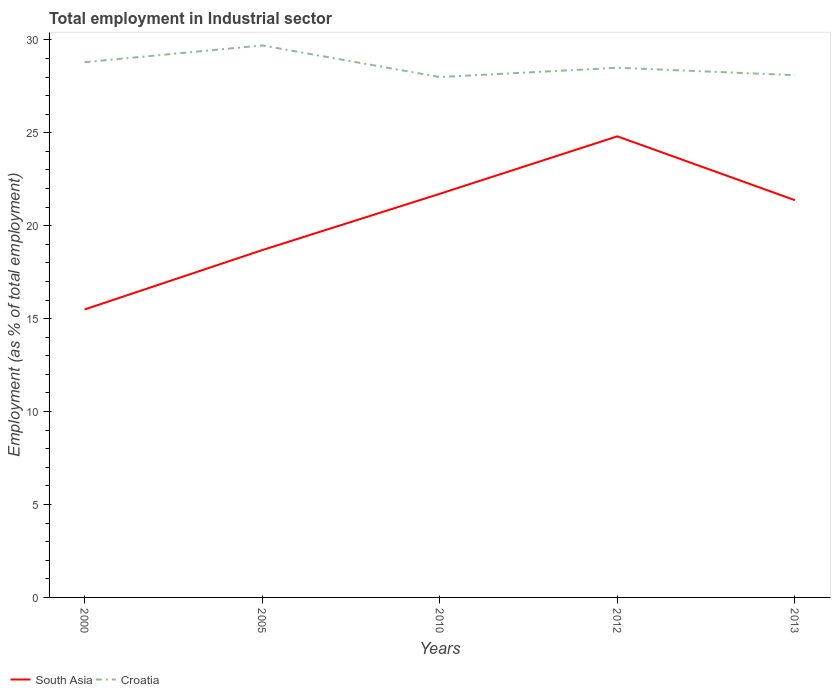How many different coloured lines are there?
Your response must be concise. 2. Does the line corresponding to South Asia intersect with the line corresponding to Croatia?
Offer a very short reply. No. Is the number of lines equal to the number of legend labels?
Make the answer very short. Yes. Across all years, what is the maximum employment in industrial sector in South Asia?
Give a very brief answer. 15.49. In which year was the employment in industrial sector in South Asia maximum?
Provide a succinct answer. 2000. What is the total employment in industrial sector in Croatia in the graph?
Offer a terse response. 0.3. What is the difference between the highest and the second highest employment in industrial sector in South Asia?
Offer a terse response. 9.31. Is the employment in industrial sector in Croatia strictly greater than the employment in industrial sector in South Asia over the years?
Ensure brevity in your answer.  No. How many lines are there?
Offer a very short reply. 2. How many years are there in the graph?
Make the answer very short. 5. What is the difference between two consecutive major ticks on the Y-axis?
Your answer should be very brief. 5. Are the values on the major ticks of Y-axis written in scientific E-notation?
Offer a very short reply. No. Does the graph contain any zero values?
Your response must be concise. No. Where does the legend appear in the graph?
Offer a very short reply. Bottom left. How are the legend labels stacked?
Your response must be concise. Horizontal. What is the title of the graph?
Provide a succinct answer. Total employment in Industrial sector. What is the label or title of the X-axis?
Provide a short and direct response. Years. What is the label or title of the Y-axis?
Provide a succinct answer. Employment (as % of total employment). What is the Employment (as % of total employment) of South Asia in 2000?
Make the answer very short. 15.49. What is the Employment (as % of total employment) in Croatia in 2000?
Your response must be concise. 28.8. What is the Employment (as % of total employment) in South Asia in 2005?
Ensure brevity in your answer.  18.69. What is the Employment (as % of total employment) in Croatia in 2005?
Provide a succinct answer. 29.7. What is the Employment (as % of total employment) of South Asia in 2010?
Offer a terse response. 21.72. What is the Employment (as % of total employment) in Croatia in 2010?
Your response must be concise. 28. What is the Employment (as % of total employment) of South Asia in 2012?
Provide a succinct answer. 24.81. What is the Employment (as % of total employment) in Croatia in 2012?
Keep it short and to the point. 28.5. What is the Employment (as % of total employment) of South Asia in 2013?
Your response must be concise. 21.37. What is the Employment (as % of total employment) in Croatia in 2013?
Offer a very short reply. 28.1. Across all years, what is the maximum Employment (as % of total employment) in South Asia?
Your answer should be very brief. 24.81. Across all years, what is the maximum Employment (as % of total employment) of Croatia?
Provide a succinct answer. 29.7. Across all years, what is the minimum Employment (as % of total employment) of South Asia?
Offer a very short reply. 15.49. What is the total Employment (as % of total employment) in South Asia in the graph?
Provide a succinct answer. 102.08. What is the total Employment (as % of total employment) in Croatia in the graph?
Your answer should be very brief. 143.1. What is the difference between the Employment (as % of total employment) of South Asia in 2000 and that in 2005?
Offer a very short reply. -3.19. What is the difference between the Employment (as % of total employment) in Croatia in 2000 and that in 2005?
Offer a very short reply. -0.9. What is the difference between the Employment (as % of total employment) in South Asia in 2000 and that in 2010?
Keep it short and to the point. -6.22. What is the difference between the Employment (as % of total employment) in South Asia in 2000 and that in 2012?
Ensure brevity in your answer.  -9.31. What is the difference between the Employment (as % of total employment) in South Asia in 2000 and that in 2013?
Your answer should be compact. -5.88. What is the difference between the Employment (as % of total employment) of South Asia in 2005 and that in 2010?
Offer a terse response. -3.03. What is the difference between the Employment (as % of total employment) of South Asia in 2005 and that in 2012?
Provide a succinct answer. -6.12. What is the difference between the Employment (as % of total employment) of Croatia in 2005 and that in 2012?
Provide a succinct answer. 1.2. What is the difference between the Employment (as % of total employment) of South Asia in 2005 and that in 2013?
Offer a terse response. -2.69. What is the difference between the Employment (as % of total employment) of Croatia in 2005 and that in 2013?
Offer a terse response. 1.6. What is the difference between the Employment (as % of total employment) in South Asia in 2010 and that in 2012?
Your answer should be very brief. -3.09. What is the difference between the Employment (as % of total employment) in South Asia in 2010 and that in 2013?
Your answer should be compact. 0.34. What is the difference between the Employment (as % of total employment) of South Asia in 2012 and that in 2013?
Your answer should be very brief. 3.44. What is the difference between the Employment (as % of total employment) of Croatia in 2012 and that in 2013?
Your answer should be compact. 0.4. What is the difference between the Employment (as % of total employment) in South Asia in 2000 and the Employment (as % of total employment) in Croatia in 2005?
Your answer should be compact. -14.21. What is the difference between the Employment (as % of total employment) in South Asia in 2000 and the Employment (as % of total employment) in Croatia in 2010?
Provide a succinct answer. -12.51. What is the difference between the Employment (as % of total employment) in South Asia in 2000 and the Employment (as % of total employment) in Croatia in 2012?
Your answer should be very brief. -13.01. What is the difference between the Employment (as % of total employment) of South Asia in 2000 and the Employment (as % of total employment) of Croatia in 2013?
Provide a short and direct response. -12.61. What is the difference between the Employment (as % of total employment) in South Asia in 2005 and the Employment (as % of total employment) in Croatia in 2010?
Ensure brevity in your answer.  -9.31. What is the difference between the Employment (as % of total employment) of South Asia in 2005 and the Employment (as % of total employment) of Croatia in 2012?
Ensure brevity in your answer.  -9.81. What is the difference between the Employment (as % of total employment) in South Asia in 2005 and the Employment (as % of total employment) in Croatia in 2013?
Give a very brief answer. -9.41. What is the difference between the Employment (as % of total employment) of South Asia in 2010 and the Employment (as % of total employment) of Croatia in 2012?
Make the answer very short. -6.78. What is the difference between the Employment (as % of total employment) of South Asia in 2010 and the Employment (as % of total employment) of Croatia in 2013?
Your answer should be very brief. -6.38. What is the difference between the Employment (as % of total employment) of South Asia in 2012 and the Employment (as % of total employment) of Croatia in 2013?
Provide a short and direct response. -3.29. What is the average Employment (as % of total employment) of South Asia per year?
Offer a terse response. 20.42. What is the average Employment (as % of total employment) in Croatia per year?
Make the answer very short. 28.62. In the year 2000, what is the difference between the Employment (as % of total employment) of South Asia and Employment (as % of total employment) of Croatia?
Offer a very short reply. -13.31. In the year 2005, what is the difference between the Employment (as % of total employment) of South Asia and Employment (as % of total employment) of Croatia?
Make the answer very short. -11.01. In the year 2010, what is the difference between the Employment (as % of total employment) in South Asia and Employment (as % of total employment) in Croatia?
Offer a terse response. -6.28. In the year 2012, what is the difference between the Employment (as % of total employment) of South Asia and Employment (as % of total employment) of Croatia?
Give a very brief answer. -3.69. In the year 2013, what is the difference between the Employment (as % of total employment) of South Asia and Employment (as % of total employment) of Croatia?
Make the answer very short. -6.73. What is the ratio of the Employment (as % of total employment) of South Asia in 2000 to that in 2005?
Keep it short and to the point. 0.83. What is the ratio of the Employment (as % of total employment) in Croatia in 2000 to that in 2005?
Offer a very short reply. 0.97. What is the ratio of the Employment (as % of total employment) of South Asia in 2000 to that in 2010?
Keep it short and to the point. 0.71. What is the ratio of the Employment (as % of total employment) of Croatia in 2000 to that in 2010?
Your answer should be compact. 1.03. What is the ratio of the Employment (as % of total employment) of South Asia in 2000 to that in 2012?
Give a very brief answer. 0.62. What is the ratio of the Employment (as % of total employment) in Croatia in 2000 to that in 2012?
Keep it short and to the point. 1.01. What is the ratio of the Employment (as % of total employment) in South Asia in 2000 to that in 2013?
Offer a terse response. 0.72. What is the ratio of the Employment (as % of total employment) in Croatia in 2000 to that in 2013?
Your response must be concise. 1.02. What is the ratio of the Employment (as % of total employment) in South Asia in 2005 to that in 2010?
Offer a terse response. 0.86. What is the ratio of the Employment (as % of total employment) in Croatia in 2005 to that in 2010?
Your response must be concise. 1.06. What is the ratio of the Employment (as % of total employment) of South Asia in 2005 to that in 2012?
Ensure brevity in your answer.  0.75. What is the ratio of the Employment (as % of total employment) in Croatia in 2005 to that in 2012?
Make the answer very short. 1.04. What is the ratio of the Employment (as % of total employment) of South Asia in 2005 to that in 2013?
Your answer should be very brief. 0.87. What is the ratio of the Employment (as % of total employment) in Croatia in 2005 to that in 2013?
Your response must be concise. 1.06. What is the ratio of the Employment (as % of total employment) of South Asia in 2010 to that in 2012?
Ensure brevity in your answer.  0.88. What is the ratio of the Employment (as % of total employment) of Croatia in 2010 to that in 2012?
Keep it short and to the point. 0.98. What is the ratio of the Employment (as % of total employment) of South Asia in 2010 to that in 2013?
Your response must be concise. 1.02. What is the ratio of the Employment (as % of total employment) of South Asia in 2012 to that in 2013?
Give a very brief answer. 1.16. What is the ratio of the Employment (as % of total employment) of Croatia in 2012 to that in 2013?
Provide a succinct answer. 1.01. What is the difference between the highest and the second highest Employment (as % of total employment) in South Asia?
Make the answer very short. 3.09. What is the difference between the highest and the second highest Employment (as % of total employment) of Croatia?
Offer a very short reply. 0.9. What is the difference between the highest and the lowest Employment (as % of total employment) in South Asia?
Give a very brief answer. 9.31. 